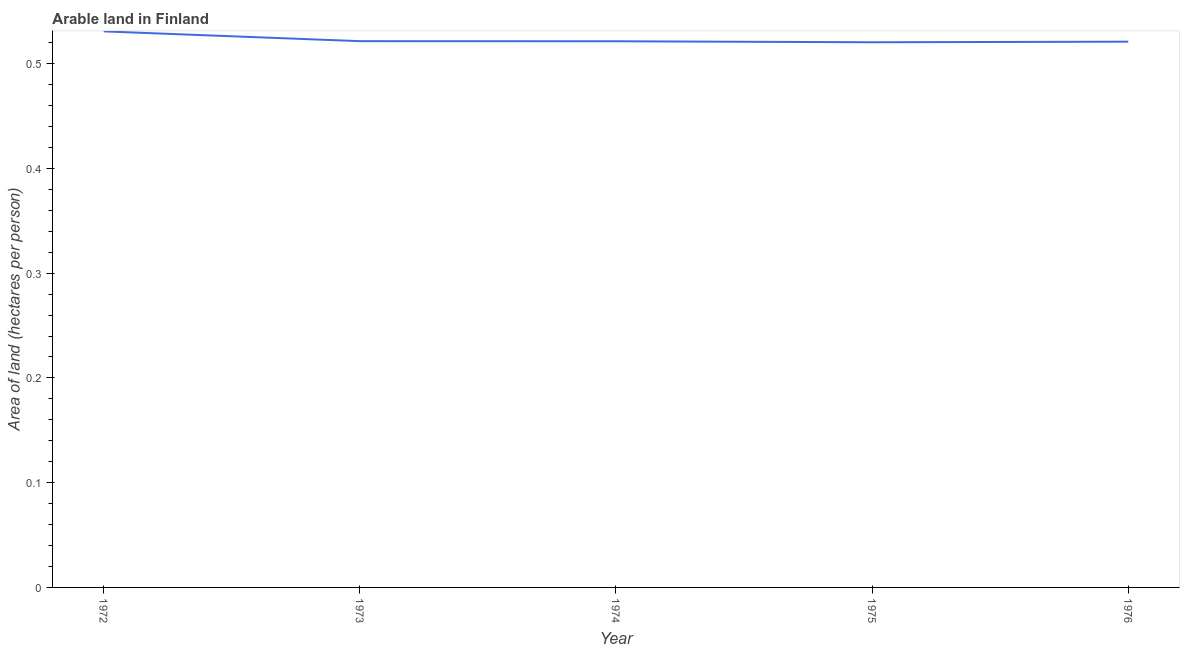What is the area of arable land in 1976?
Provide a succinct answer. 0.52. Across all years, what is the maximum area of arable land?
Provide a succinct answer. 0.53. Across all years, what is the minimum area of arable land?
Your answer should be compact. 0.52. In which year was the area of arable land minimum?
Give a very brief answer. 1975. What is the sum of the area of arable land?
Your response must be concise. 2.61. What is the difference between the area of arable land in 1973 and 1974?
Provide a succinct answer. 0. What is the average area of arable land per year?
Make the answer very short. 0.52. What is the median area of arable land?
Your answer should be very brief. 0.52. What is the ratio of the area of arable land in 1972 to that in 1975?
Keep it short and to the point. 1.02. What is the difference between the highest and the second highest area of arable land?
Offer a very short reply. 0.01. Is the sum of the area of arable land in 1973 and 1974 greater than the maximum area of arable land across all years?
Your answer should be very brief. Yes. What is the difference between the highest and the lowest area of arable land?
Offer a very short reply. 0.01. In how many years, is the area of arable land greater than the average area of arable land taken over all years?
Provide a succinct answer. 1. Does the area of arable land monotonically increase over the years?
Your response must be concise. No. How many years are there in the graph?
Ensure brevity in your answer.  5. What is the difference between two consecutive major ticks on the Y-axis?
Keep it short and to the point. 0.1. What is the title of the graph?
Provide a succinct answer. Arable land in Finland. What is the label or title of the Y-axis?
Give a very brief answer. Area of land (hectares per person). What is the Area of land (hectares per person) in 1972?
Give a very brief answer. 0.53. What is the Area of land (hectares per person) in 1973?
Offer a very short reply. 0.52. What is the Area of land (hectares per person) in 1974?
Offer a very short reply. 0.52. What is the Area of land (hectares per person) in 1975?
Offer a terse response. 0.52. What is the Area of land (hectares per person) of 1976?
Offer a terse response. 0.52. What is the difference between the Area of land (hectares per person) in 1972 and 1973?
Provide a short and direct response. 0.01. What is the difference between the Area of land (hectares per person) in 1972 and 1974?
Provide a succinct answer. 0.01. What is the difference between the Area of land (hectares per person) in 1972 and 1975?
Offer a terse response. 0.01. What is the difference between the Area of land (hectares per person) in 1972 and 1976?
Provide a short and direct response. 0.01. What is the difference between the Area of land (hectares per person) in 1973 and 1974?
Provide a short and direct response. 0. What is the difference between the Area of land (hectares per person) in 1973 and 1975?
Provide a short and direct response. 0. What is the difference between the Area of land (hectares per person) in 1973 and 1976?
Offer a very short reply. 0. What is the difference between the Area of land (hectares per person) in 1974 and 1975?
Your answer should be compact. 0. What is the difference between the Area of land (hectares per person) in 1974 and 1976?
Offer a terse response. 0. What is the difference between the Area of land (hectares per person) in 1975 and 1976?
Give a very brief answer. -0. What is the ratio of the Area of land (hectares per person) in 1972 to that in 1973?
Ensure brevity in your answer.  1.02. What is the ratio of the Area of land (hectares per person) in 1972 to that in 1976?
Provide a succinct answer. 1.02. What is the ratio of the Area of land (hectares per person) in 1973 to that in 1976?
Ensure brevity in your answer.  1. 